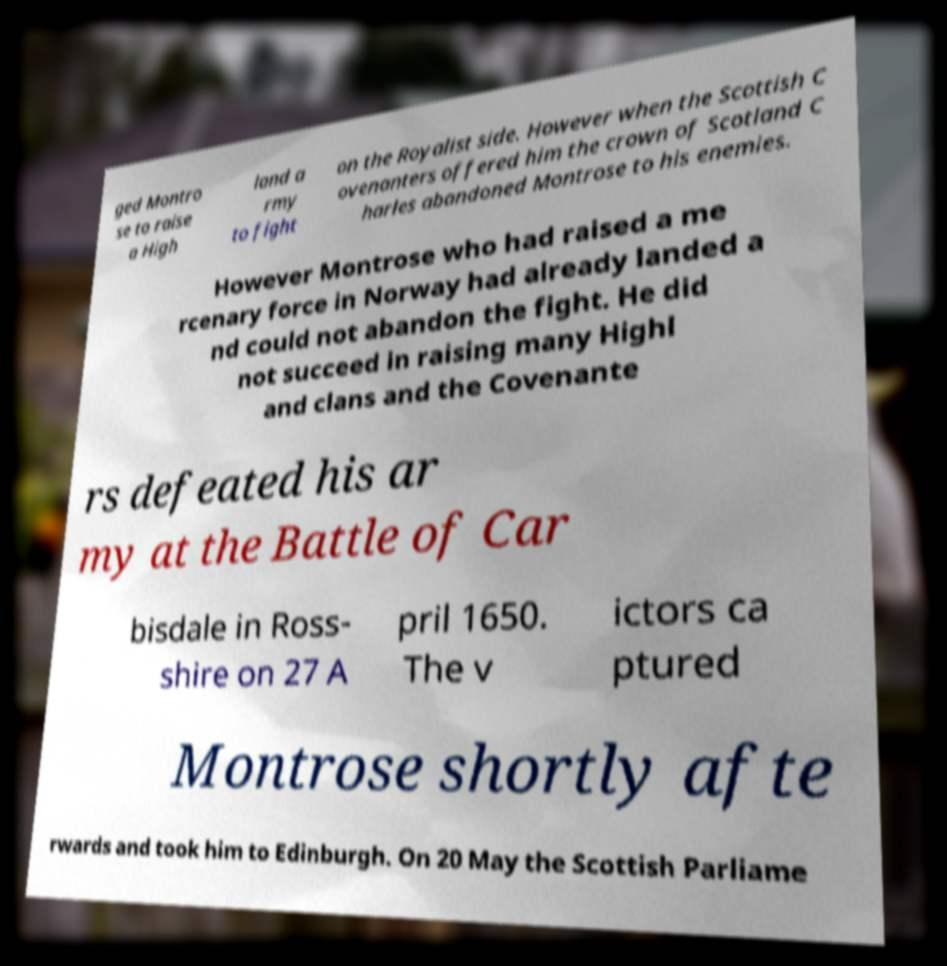Please identify and transcribe the text found in this image. ged Montro se to raise a High land a rmy to fight on the Royalist side. However when the Scottish C ovenanters offered him the crown of Scotland C harles abandoned Montrose to his enemies. However Montrose who had raised a me rcenary force in Norway had already landed a nd could not abandon the fight. He did not succeed in raising many Highl and clans and the Covenante rs defeated his ar my at the Battle of Car bisdale in Ross- shire on 27 A pril 1650. The v ictors ca ptured Montrose shortly afte rwards and took him to Edinburgh. On 20 May the Scottish Parliame 